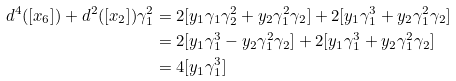Convert formula to latex. <formula><loc_0><loc_0><loc_500><loc_500>d ^ { 4 } ( [ x _ { 6 } ] ) + d ^ { 2 } ( [ x _ { 2 } ] ) \gamma _ { 1 } ^ { 2 } & = 2 [ y _ { 1 } \gamma _ { 1 } \gamma _ { 2 } ^ { 2 } + y _ { 2 } \gamma _ { 1 } ^ { 2 } \gamma _ { 2 } ] + 2 [ y _ { 1 } \gamma _ { 1 } ^ { 3 } + y _ { 2 } \gamma _ { 1 } ^ { 2 } \gamma _ { 2 } ] \\ & = 2 [ y _ { 1 } \gamma _ { 1 } ^ { 3 } - y _ { 2 } \gamma _ { 1 } ^ { 2 } \gamma _ { 2 } ] + 2 [ y _ { 1 } \gamma _ { 1 } ^ { 3 } + y _ { 2 } \gamma _ { 1 } ^ { 2 } \gamma _ { 2 } ] \\ & = 4 [ y _ { 1 } \gamma _ { 1 } ^ { 3 } ]</formula> 